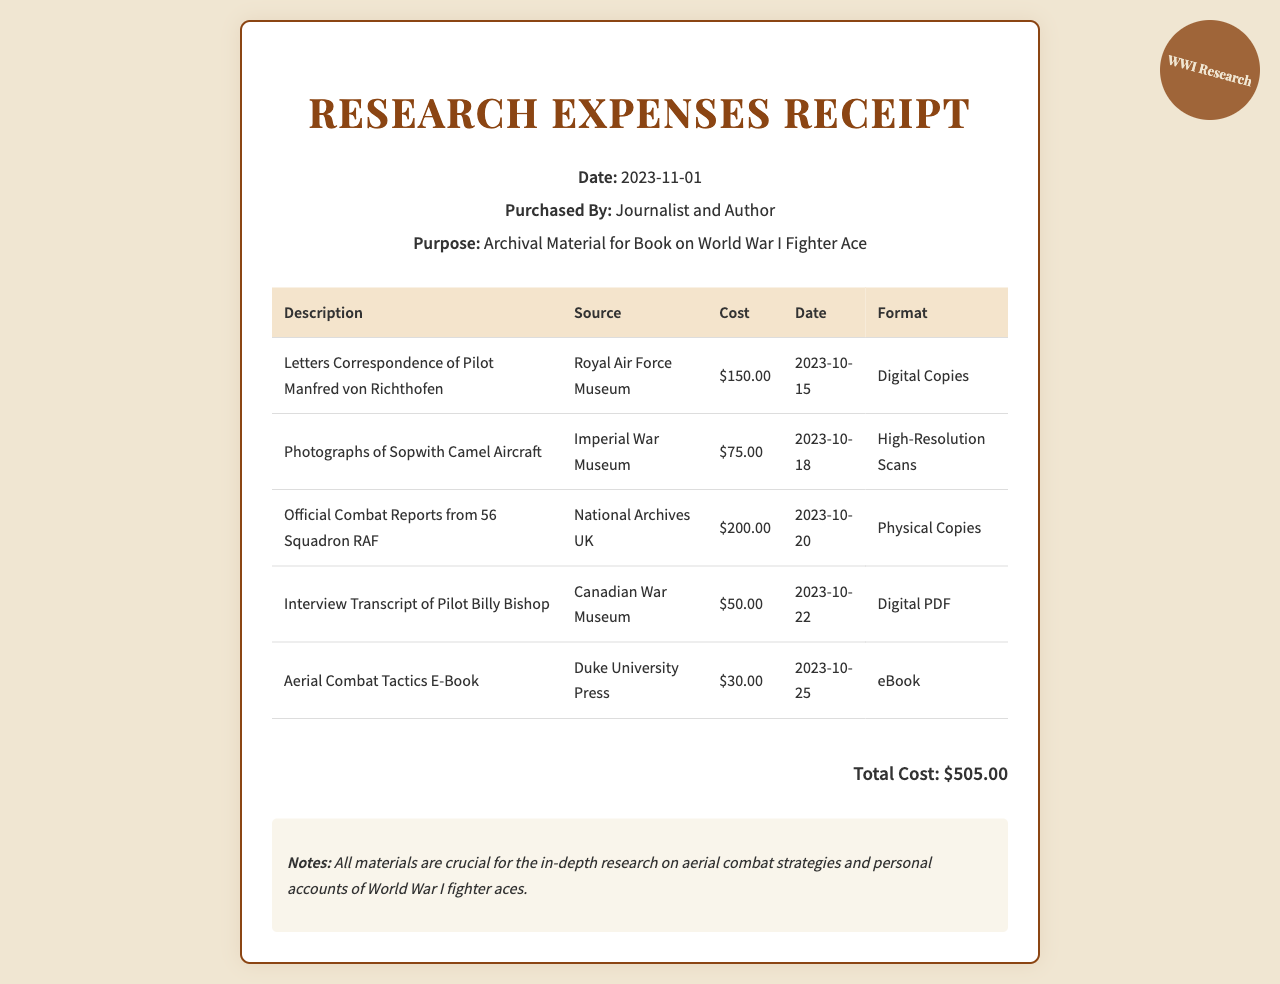What is the date of the receipt? The date of the receipt is specified in the document, which shows "2023-11-01."
Answer: 2023-11-01 Who purchased the archival material? The document mentions the individual who made the purchase, stating "Journalist and Author."
Answer: Journalist and Author What is the total cost of the research expenses? The document calculates the total cost by summing the individual costs, which is "$505.00."
Answer: $505.00 How many photographs of aircraft were purchased? The document lists "Photographs of Sopwith Camel Aircraft" as one of the items, indicating it is the only purchase related to photographs.
Answer: 1 Which institution provided the letters correspondence? The document identifies the source of the letters correspondence as "Royal Air Force Museum."
Answer: Royal Air Force Museum What is the format of the official combat reports? The document specifies the format of the official combat reports as "Physical Copies."
Answer: Physical Copies What was the cost of the aerial combat tactics e-book? The document indicates that the cost of the "Aerial Combat Tactics E-Book" is "$30.00."
Answer: $30.00 How many items are listed in the receipt? By counting the entries in the table of the document, there are five items listed.
Answer: 5 What type of materials are noted as crucial for research? The notes section of the document emphasizes that all materials are crucial for research on "aerial combat strategies and personal accounts."
Answer: Aerial combat strategies and personal accounts 